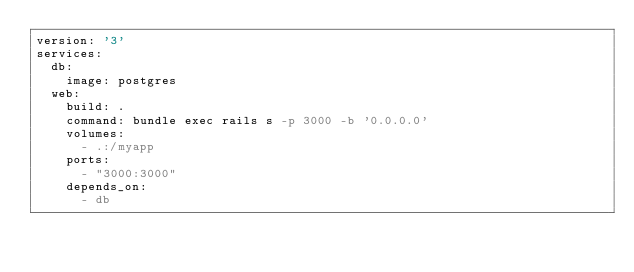Convert code to text. <code><loc_0><loc_0><loc_500><loc_500><_YAML_>version: '3'
services:
  db:
    image: postgres
  web:
    build: .
    command: bundle exec rails s -p 3000 -b '0.0.0.0'
    volumes:
      - .:/myapp
    ports:
      - "3000:3000"
    depends_on:
      - db
</code> 